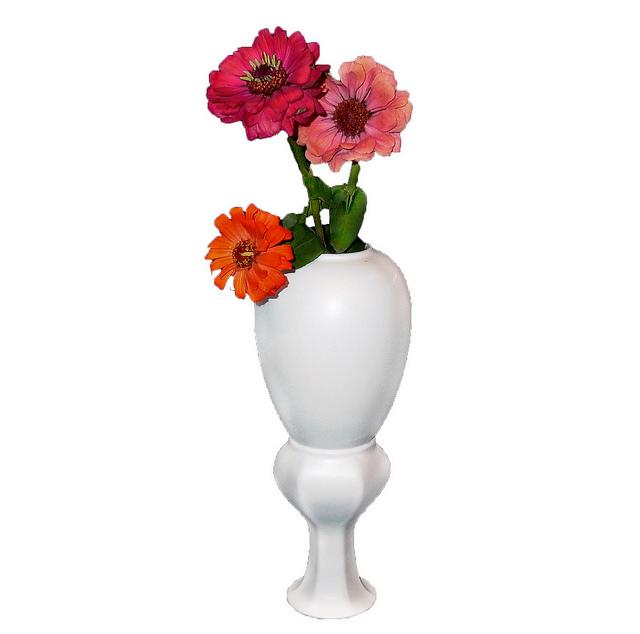How many flowers are in the vase?
Write a very short answer. 3. Has the background been deleted?
Write a very short answer. Yes. Are the flowers are the same height?
Give a very brief answer. No. 